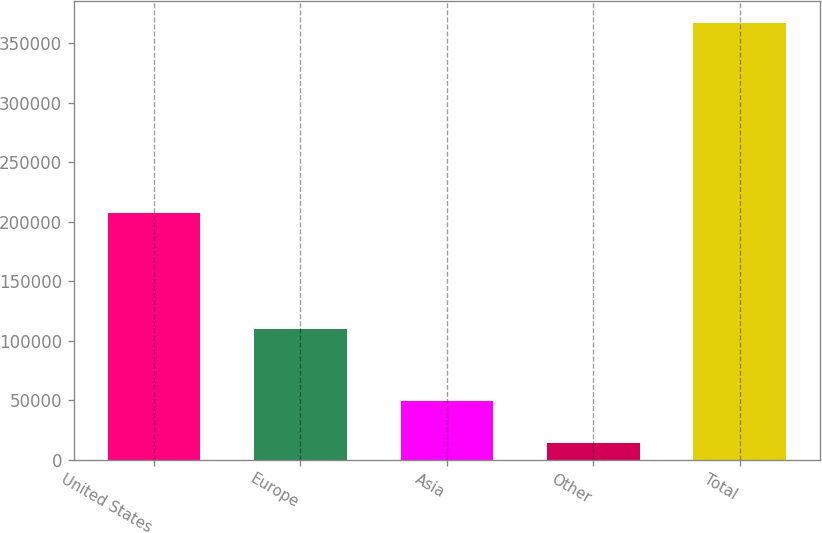Convert chart. <chart><loc_0><loc_0><loc_500><loc_500><bar_chart><fcel>United States<fcel>Europe<fcel>Asia<fcel>Other<fcel>Total<nl><fcel>207692<fcel>109556<fcel>49636.3<fcel>14396<fcel>366799<nl></chart> 